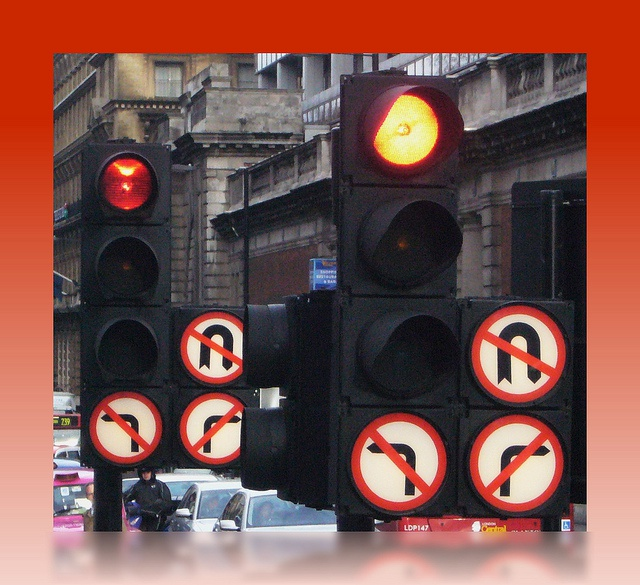Describe the objects in this image and their specific colors. I can see traffic light in red, black, beige, and maroon tones, traffic light in red, black, beige, and brown tones, car in red, gray, lightgray, and darkgray tones, car in red, lavender, gray, violet, and darkgray tones, and car in red, white, gray, and darkgray tones in this image. 